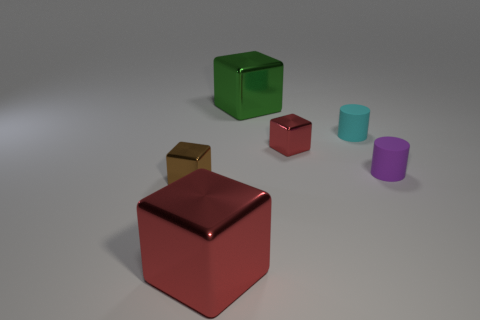How many things are tiny blocks that are behind the tiny purple thing or small brown cubes that are to the left of the green cube?
Offer a very short reply. 2. What color is the other thing that is the same shape as the small purple object?
Your answer should be compact. Cyan. Are there any other things that are the same shape as the tiny purple thing?
Offer a terse response. Yes. There is a tiny purple object; is its shape the same as the metallic object that is right of the green thing?
Your response must be concise. No. What material is the cyan thing?
Provide a succinct answer. Rubber. What is the size of the green metallic object that is the same shape as the brown shiny object?
Ensure brevity in your answer.  Large. How many other objects are there of the same material as the large red thing?
Your response must be concise. 3. Is the material of the cyan object the same as the small thing that is to the left of the green shiny thing?
Offer a terse response. No. Are there fewer cyan rubber cylinders that are in front of the small purple matte thing than large red metal things to the right of the tiny brown object?
Provide a succinct answer. Yes. What color is the big object that is in front of the small purple rubber object?
Keep it short and to the point. Red. 